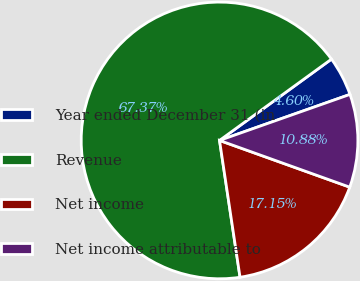Convert chart to OTSL. <chart><loc_0><loc_0><loc_500><loc_500><pie_chart><fcel>Year ended December 31 (in<fcel>Revenue<fcel>Net income<fcel>Net income attributable to<nl><fcel>4.6%<fcel>67.37%<fcel>17.15%<fcel>10.88%<nl></chart> 